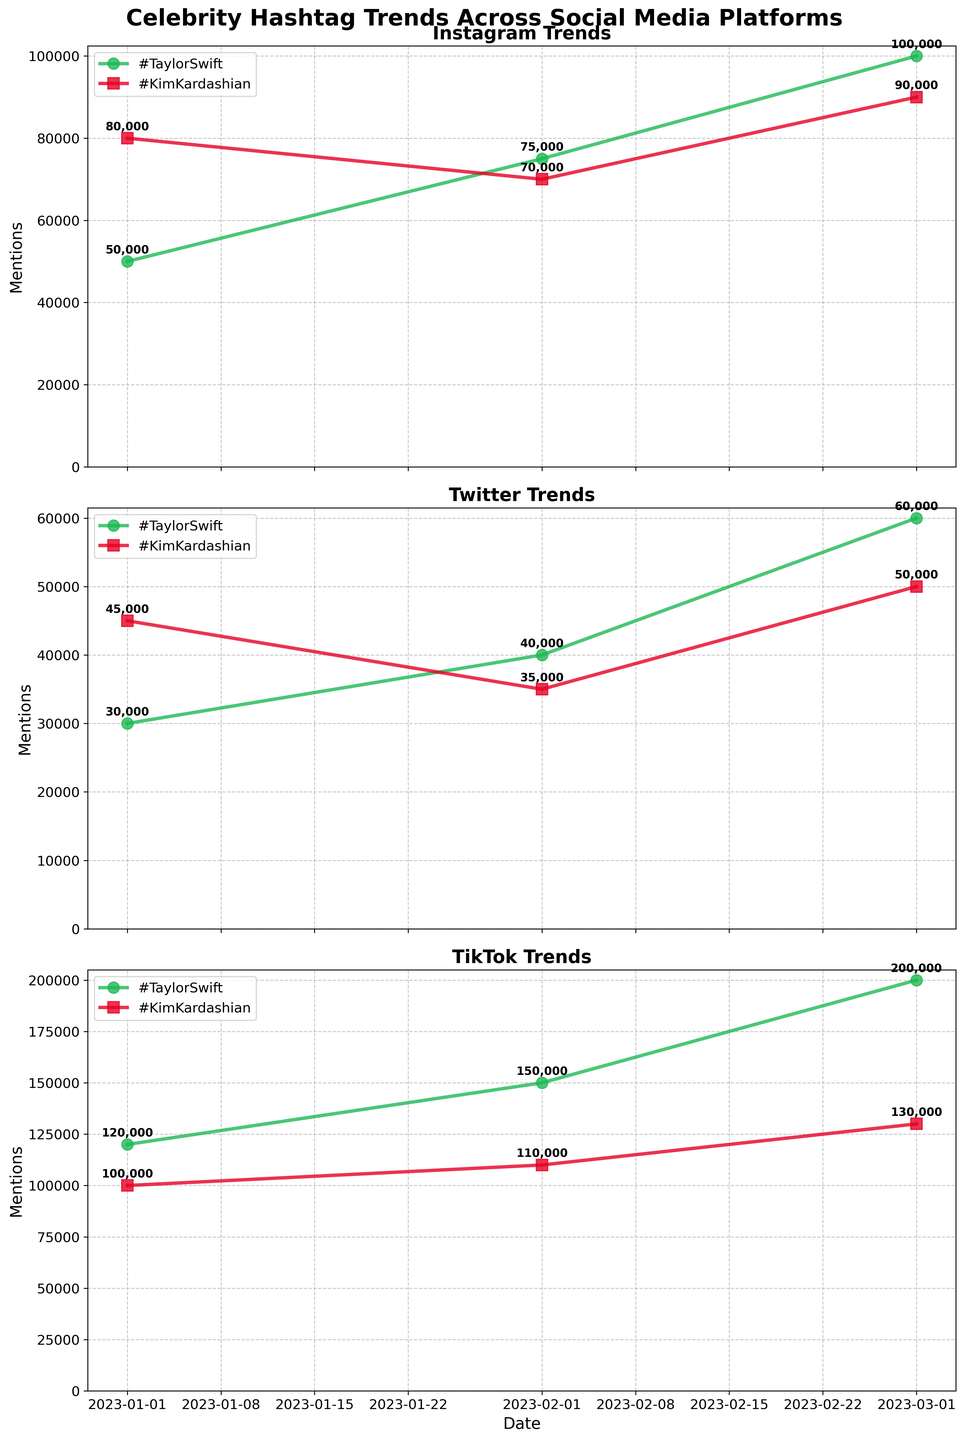What's the title of the figure? The title is located at the top of each figure and usually bold. The figure's title reads "Celebrity Hashtag Trends Across Social Media Platforms."
Answer: Celebrity Hashtag Trends Across Social Media Platforms On which platform did #TaylorSwift have the highest mentions in March 2023? The March 2023 mentions for #TaylorSwift are represented by different data points in the plot of each platform. Looking at the highest point, it is TikTok where it reached 200,000 mentions.
Answer: TikTok What is the difference in mentions for #KimKardashian between January and March 2023 on Instagram? Look at the Instagram subplot. The mentions in January 2023 were 80,000 and in March 2023 were 90,000. The difference is calculated as 90,000 - 80,000 = 10,000.
Answer: 10,000 Which hashtag had a greater increase in mentions from January to March 2023 on Twitter? Looking at Twitter subplot, #TaylorSwift went from 30,000 to 60,000 (an increase of 30,000) and #KimKardashian went from 45,000 to 50,000 (an increase of 5,000). Therefore, #TaylorSwift had a greater increase.
Answer: #TaylorSwift Which month had the lowest mentions for #KimKardashian on any platform? By checking all subplots, the lowest mention for #KimKardashian is in February 2023 on Twitter which is 35,000.
Answer: February 2023 How do the trends of #TaylorSwift and #KimKardashian differ on TikTok from January to March 2023? On TikTok, observe both lines' progression from January to March 2023. #TaylorSwift shows a steep upward trend from 120,000 to 200,000, while #KimKardashian demonstrates a less steep increase from 100,000 to 130,000.
Answer: #TaylorSwift had a steeper increase What is the range of mentions for #TaylorSwift on Instagram over the given period? The range is the difference between the highest and lowest points for #TaylorSwift on Instagram. Highest is 100,000 (March 2023) and lowest is 50,000 (January 2023). Range = 100,000 - 50,000 = 50,000.
Answer: 50,000 Between Taylor Swift and Kim Kardashian, who had more mentions overall on Instagram in February 2023? For February 2023 on Instagram, #TaylorSwift had 75,000 mentions and #KimKardashian had 70,000 mentions. Thus, Taylor Swift had more mentions.
Answer: Taylor Swift What pattern do you observe in mentions for #KimKardashian across all platforms? Reviewing each subplot, #KimKardashian mentions vary. Instagram: decline then rise (80,000 to 90,000), Twitter: decline then rise (45,000 to 50,000), TikTok: steady increase (100,000 to 130,000). A mixed pattern of rise and decline except on TikTok.
Answer: Mixed pattern From January to March 2023, which platform showed the largest overall increase in mentions for any hashtag? Check the slopes in all subplots. TikTok shows the largest increase for #TaylorSwift from 120,000 to 200,000, yielding an overall increase of 80,000 mentions.
Answer: TikTok for #TaylorSwift 